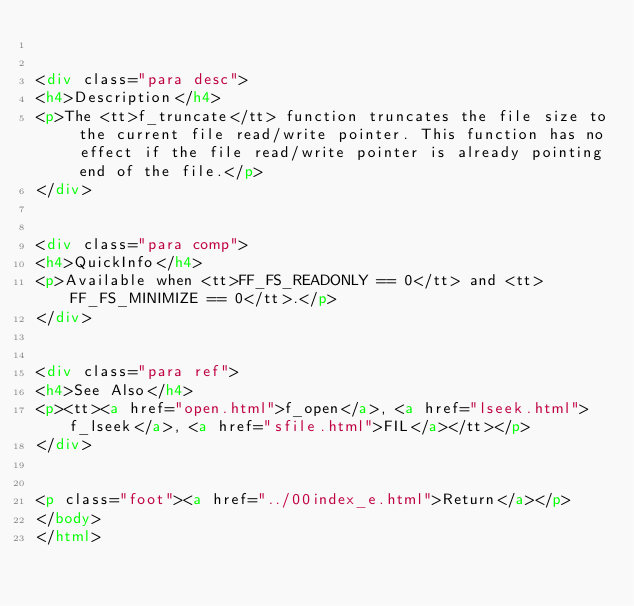<code> <loc_0><loc_0><loc_500><loc_500><_HTML_>

<div class="para desc">
<h4>Description</h4>
<p>The <tt>f_truncate</tt> function truncates the file size to the current file read/write pointer. This function has no effect if the file read/write pointer is already pointing end of the file.</p>
</div>


<div class="para comp">
<h4>QuickInfo</h4>
<p>Available when <tt>FF_FS_READONLY == 0</tt> and <tt>FF_FS_MINIMIZE == 0</tt>.</p>
</div>


<div class="para ref">
<h4>See Also</h4>
<p><tt><a href="open.html">f_open</a>, <a href="lseek.html">f_lseek</a>, <a href="sfile.html">FIL</a></tt></p>
</div>


<p class="foot"><a href="../00index_e.html">Return</a></p>
</body>
</html>
</code> 